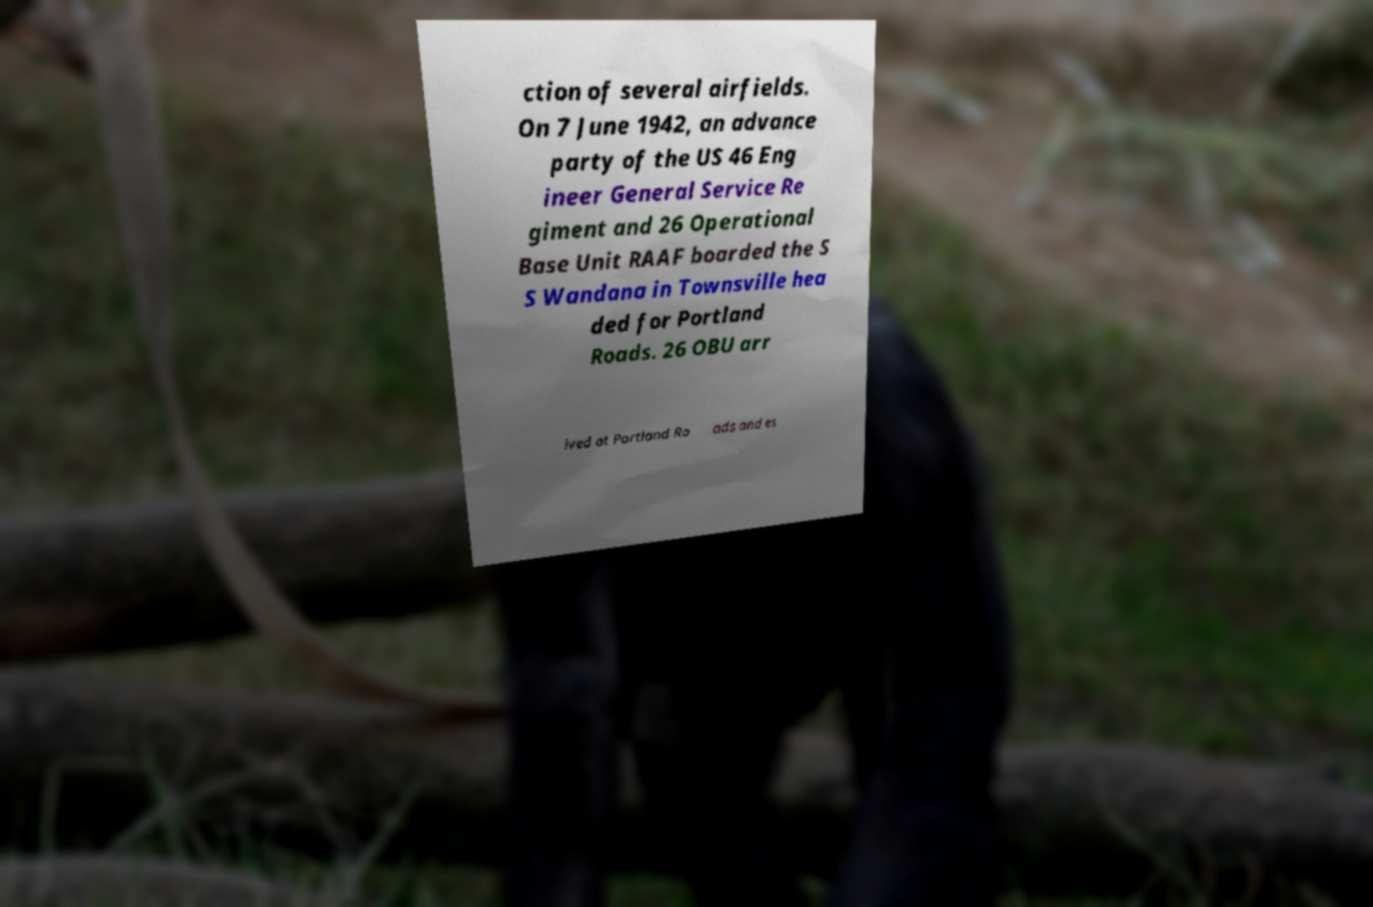Could you extract and type out the text from this image? ction of several airfields. On 7 June 1942, an advance party of the US 46 Eng ineer General Service Re giment and 26 Operational Base Unit RAAF boarded the S S Wandana in Townsville hea ded for Portland Roads. 26 OBU arr ived at Portland Ro ads and es 